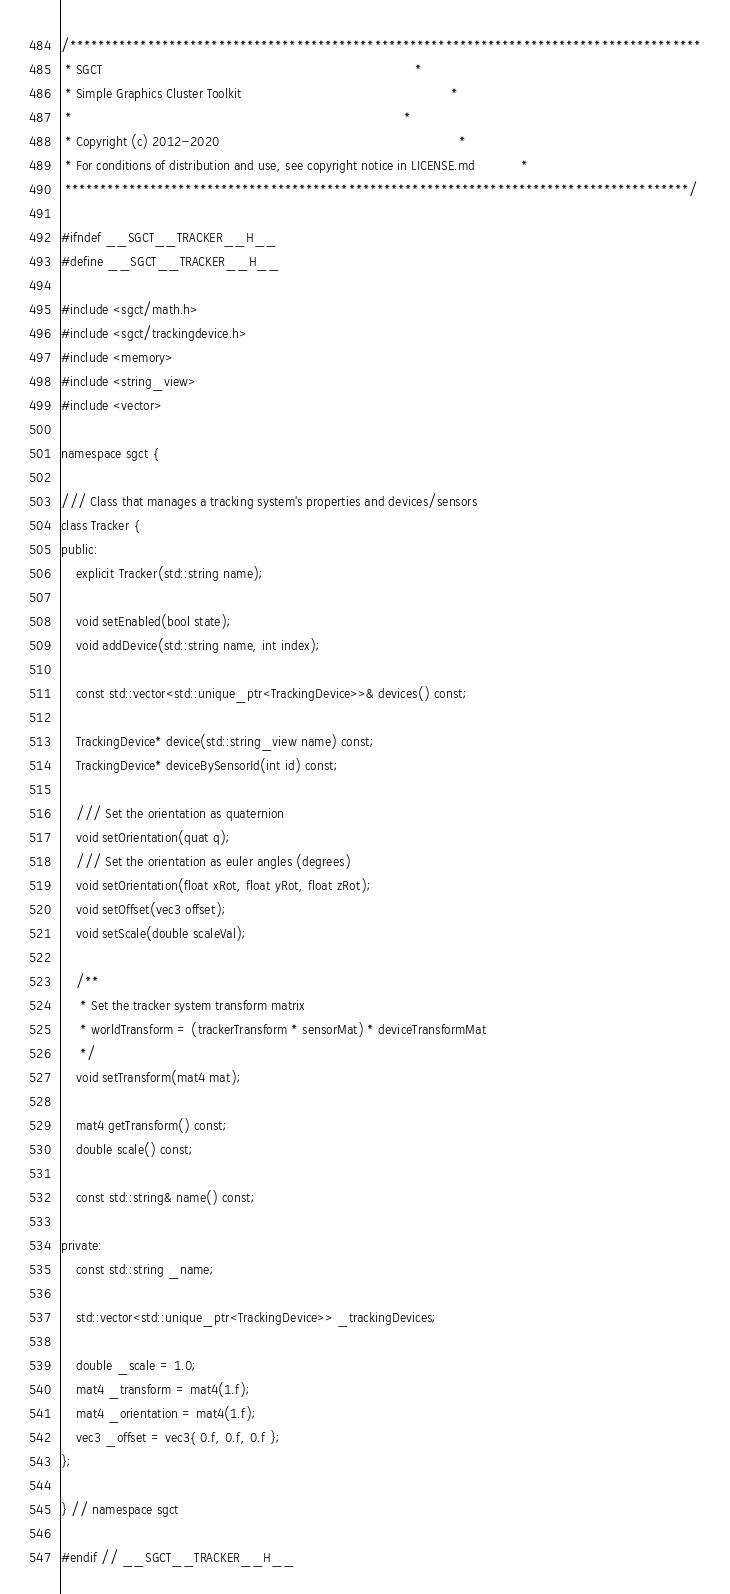<code> <loc_0><loc_0><loc_500><loc_500><_C_>/*****************************************************************************************
 * SGCT                                                                                  *
 * Simple Graphics Cluster Toolkit                                                       *
 *                                                                                       *
 * Copyright (c) 2012-2020                                                               *
 * For conditions of distribution and use, see copyright notice in LICENSE.md            *
 ****************************************************************************************/

#ifndef __SGCT__TRACKER__H__
#define __SGCT__TRACKER__H__

#include <sgct/math.h>
#include <sgct/trackingdevice.h>
#include <memory>
#include <string_view>
#include <vector>

namespace sgct {

/// Class that manages a tracking system's properties and devices/sensors
class Tracker {
public:
    explicit Tracker(std::string name);

    void setEnabled(bool state);
    void addDevice(std::string name, int index);

    const std::vector<std::unique_ptr<TrackingDevice>>& devices() const;

    TrackingDevice* device(std::string_view name) const;
    TrackingDevice* deviceBySensorId(int id) const;

    /// Set the orientation as quaternion
    void setOrientation(quat q);
    /// Set the orientation as euler angles (degrees)
    void setOrientation(float xRot, float yRot, float zRot);
    void setOffset(vec3 offset);
    void setScale(double scaleVal);

    /**
     * Set the tracker system transform matrix
     * worldTransform = (trackerTransform * sensorMat) * deviceTransformMat
     */
    void setTransform(mat4 mat);

    mat4 getTransform() const;
    double scale() const;

    const std::string& name() const;

private:
    const std::string _name;

    std::vector<std::unique_ptr<TrackingDevice>> _trackingDevices;

    double _scale = 1.0;
    mat4 _transform = mat4(1.f);
    mat4 _orientation = mat4(1.f);
    vec3 _offset = vec3{ 0.f, 0.f, 0.f };
};

} // namespace sgct

#endif // __SGCT__TRACKER__H__
</code> 